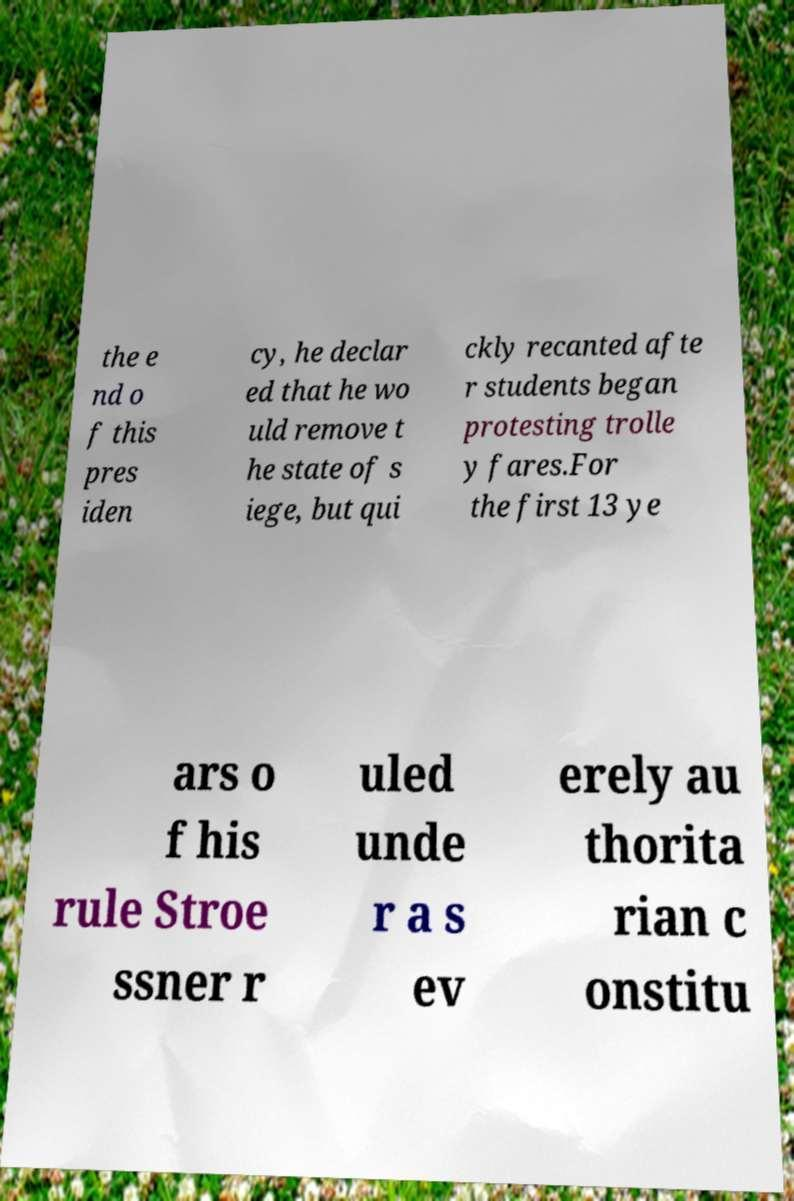There's text embedded in this image that I need extracted. Can you transcribe it verbatim? the e nd o f this pres iden cy, he declar ed that he wo uld remove t he state of s iege, but qui ckly recanted afte r students began protesting trolle y fares.For the first 13 ye ars o f his rule Stroe ssner r uled unde r a s ev erely au thorita rian c onstitu 